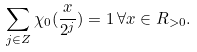Convert formula to latex. <formula><loc_0><loc_0><loc_500><loc_500>\sum _ { j \in { Z } } \chi _ { 0 } ( \frac { x } { 2 ^ { j } } ) = 1 \, \forall x \in { R } _ { > 0 } .</formula> 